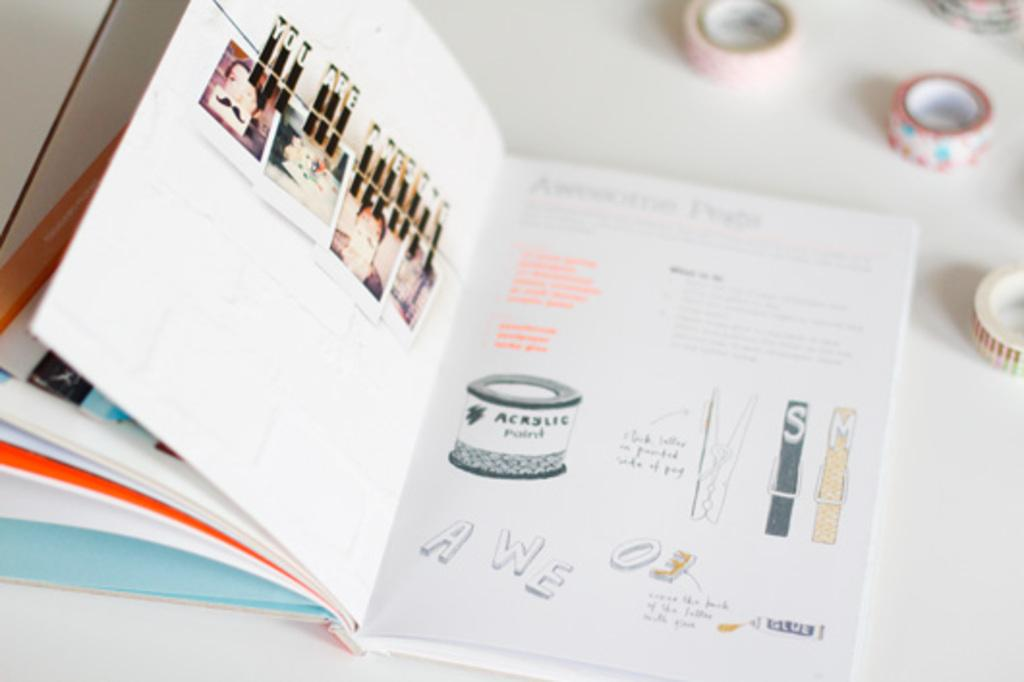<image>
Summarize the visual content of the image. On the left page the paper clips spell out you are awesome 